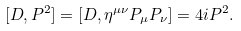<formula> <loc_0><loc_0><loc_500><loc_500>[ D , P ^ { 2 } ] = [ D , \eta ^ { \mu \nu } P _ { \mu } P _ { \nu } ] = 4 i P ^ { 2 } .</formula> 